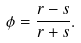<formula> <loc_0><loc_0><loc_500><loc_500>\phi = \frac { r - s } { r + s } .</formula> 